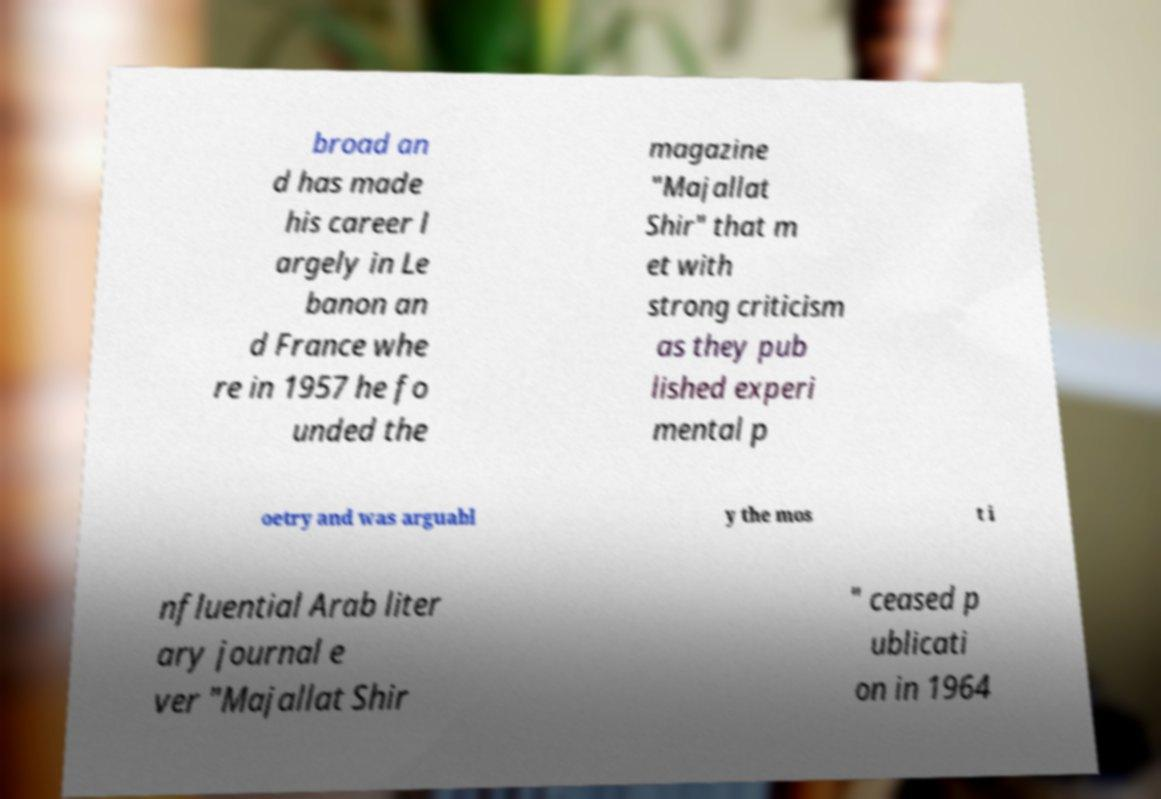What messages or text are displayed in this image? I need them in a readable, typed format. broad an d has made his career l argely in Le banon an d France whe re in 1957 he fo unded the magazine "Majallat Shir" that m et with strong criticism as they pub lished experi mental p oetry and was arguabl y the mos t i nfluential Arab liter ary journal e ver "Majallat Shir " ceased p ublicati on in 1964 